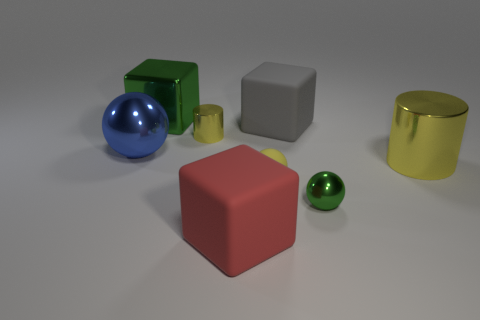What material is the sphere that is the same color as the big metallic cylinder?
Offer a terse response. Rubber. There is a green block that is made of the same material as the small yellow cylinder; what size is it?
Provide a succinct answer. Large. How many yellow metallic balls have the same size as the red block?
Ensure brevity in your answer.  0. What size is the ball that is the same color as the large metal cube?
Offer a terse response. Small. What color is the small metallic object that is on the right side of the tiny object behind the tiny rubber thing?
Provide a short and direct response. Green. Are there any spheres that have the same color as the big cylinder?
Provide a short and direct response. Yes. The ball that is the same size as the green block is what color?
Offer a very short reply. Blue. Is the material of the yellow thing that is on the left side of the tiny rubber thing the same as the yellow ball?
Ensure brevity in your answer.  No. There is a green thing that is left of the large thing in front of the yellow rubber thing; is there a big matte thing behind it?
Offer a very short reply. No. Do the big metallic object that is to the right of the big red rubber block and the small yellow metal object have the same shape?
Provide a succinct answer. Yes. 